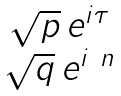Convert formula to latex. <formula><loc_0><loc_0><loc_500><loc_500>\begin{matrix} \sqrt { p } \, e ^ { i \tau } \\ \sqrt { q } \, e ^ { i \ n } \end{matrix}</formula> 